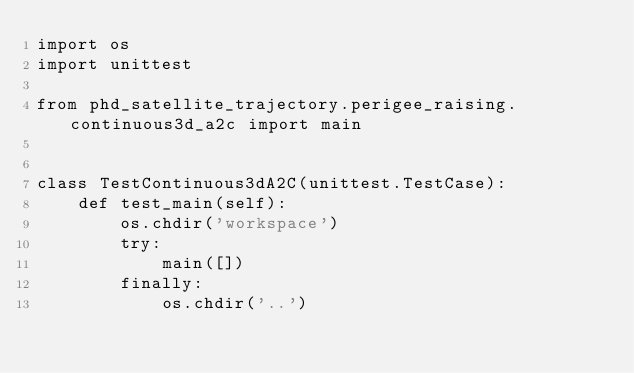<code> <loc_0><loc_0><loc_500><loc_500><_Python_>import os
import unittest

from phd_satellite_trajectory.perigee_raising.continuous3d_a2c import main


class TestContinuous3dA2C(unittest.TestCase):
    def test_main(self):
        os.chdir('workspace')
        try:
            main([])
        finally:
            os.chdir('..')
</code> 